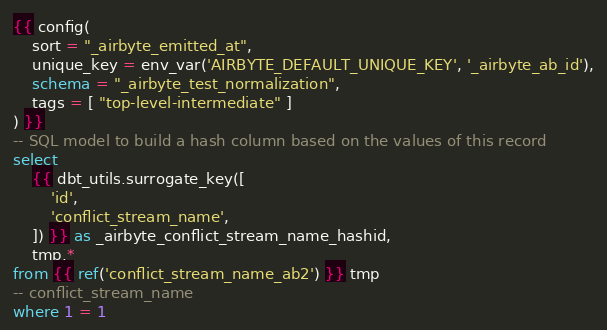Convert code to text. <code><loc_0><loc_0><loc_500><loc_500><_SQL_>{{ config(
    sort = "_airbyte_emitted_at",
    unique_key = env_var('AIRBYTE_DEFAULT_UNIQUE_KEY', '_airbyte_ab_id'),
    schema = "_airbyte_test_normalization",
    tags = [ "top-level-intermediate" ]
) }}
-- SQL model to build a hash column based on the values of this record
select
    {{ dbt_utils.surrogate_key([
        'id',
        'conflict_stream_name',
    ]) }} as _airbyte_conflict_stream_name_hashid,
    tmp.*
from {{ ref('conflict_stream_name_ab2') }} tmp
-- conflict_stream_name
where 1 = 1

</code> 